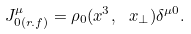<formula> <loc_0><loc_0><loc_500><loc_500>J _ { 0 ( r . f ) } ^ { \mu } = \rho _ { 0 } ( x ^ { 3 } , \ x _ { \perp } ) \delta ^ { \mu 0 } .</formula> 